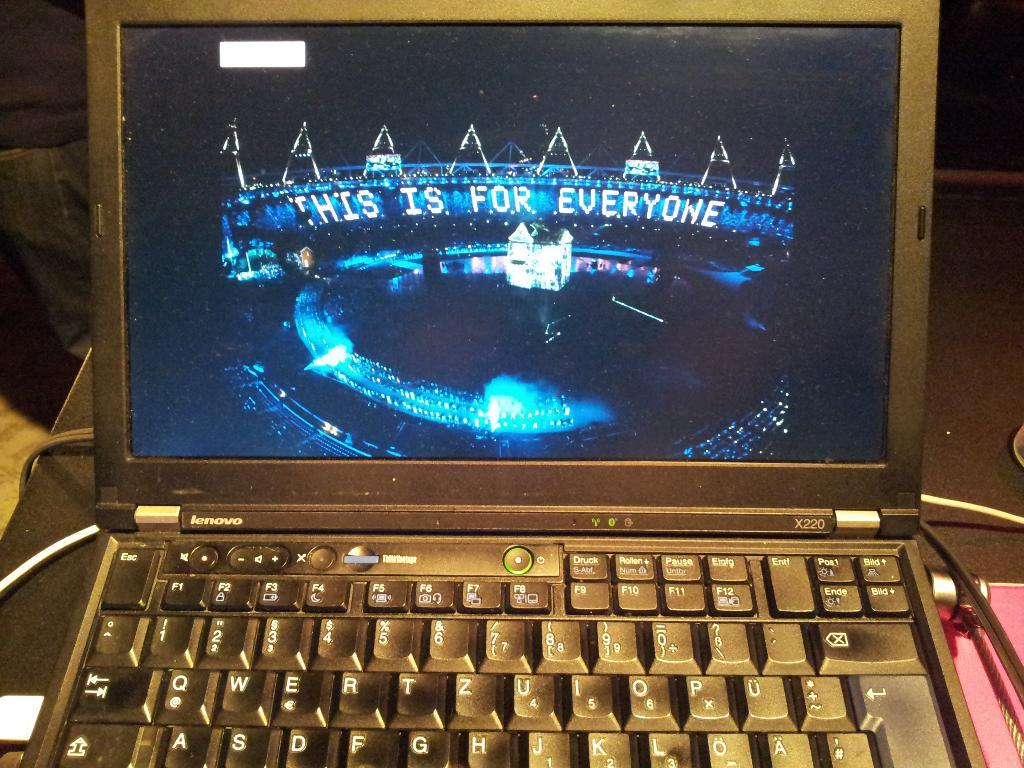Provide a one-sentence caption for the provided image. A laptop with a screen displaying the words This is for Everyone. 